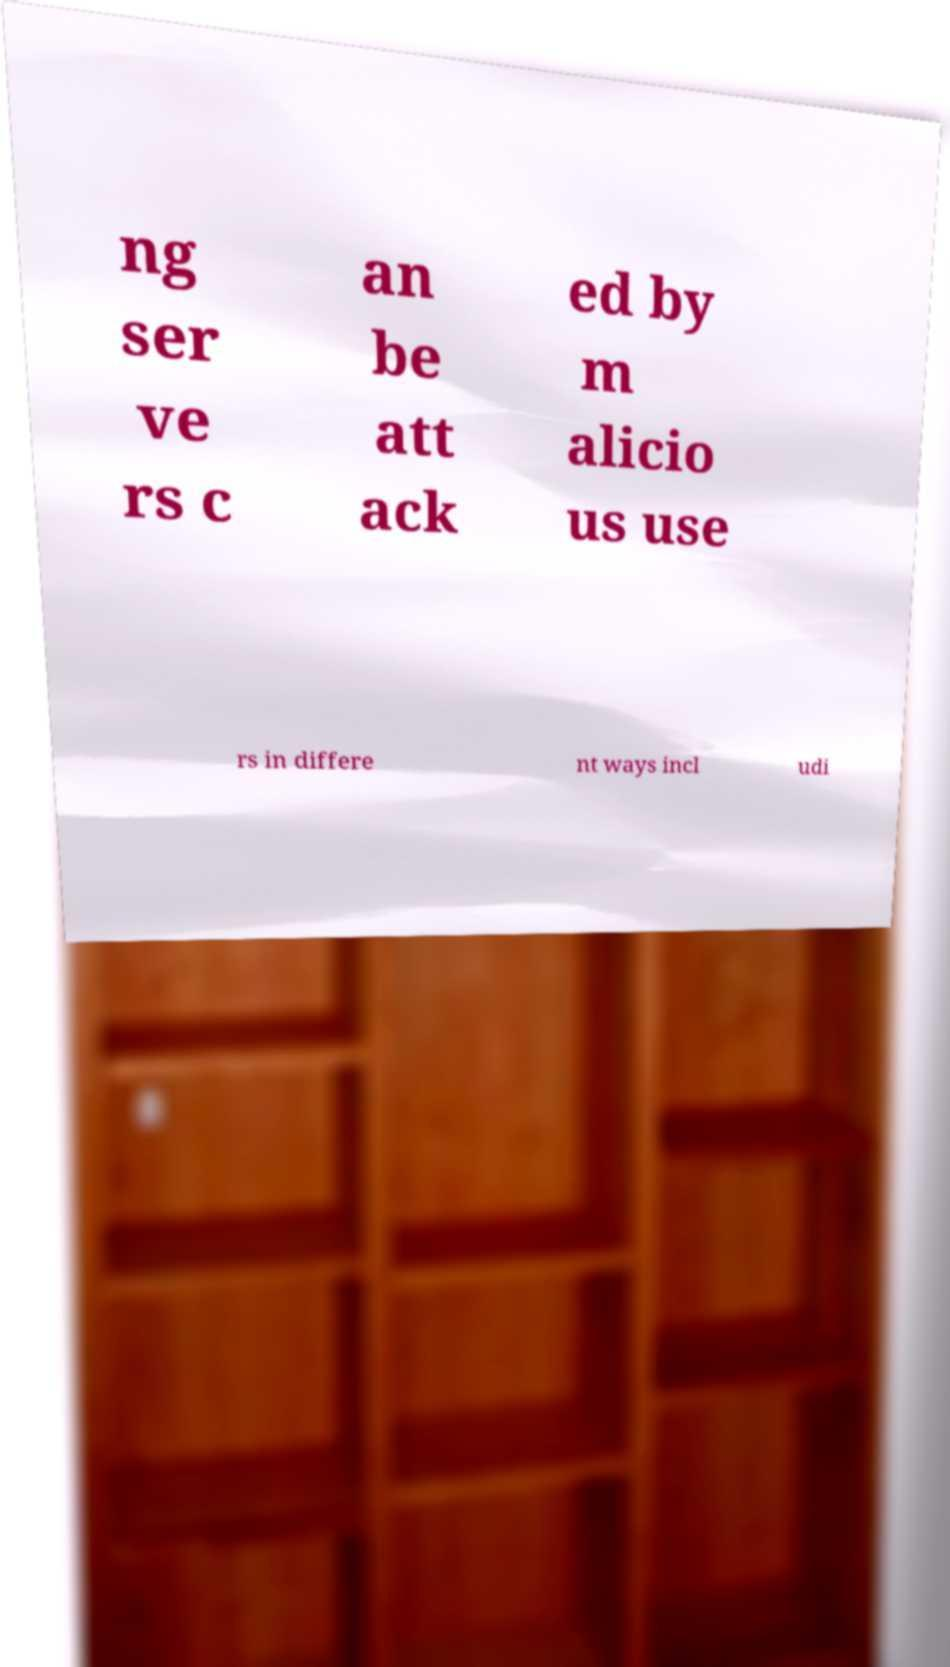Could you extract and type out the text from this image? ng ser ve rs c an be att ack ed by m alicio us use rs in differe nt ways incl udi 